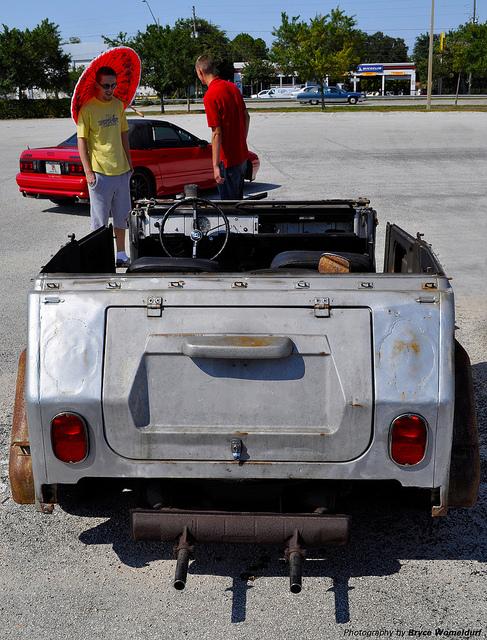Where is the red car?
Answer briefly. In front. What color is the car behind the people?
Short answer required. Red. Does this vehicle look street legal?
Short answer required. No. 